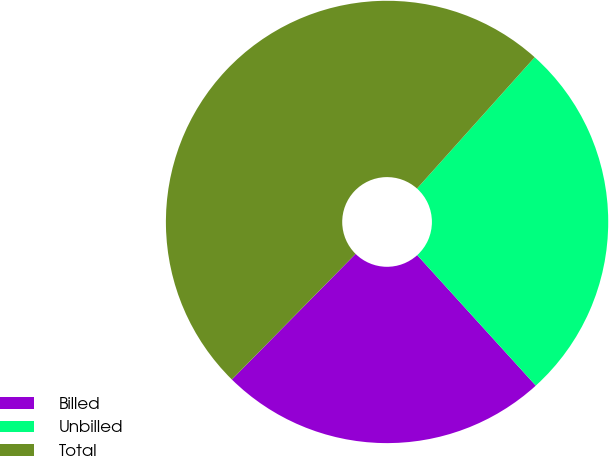Convert chart. <chart><loc_0><loc_0><loc_500><loc_500><pie_chart><fcel>Billed<fcel>Unbilled<fcel>Total<nl><fcel>24.12%<fcel>26.63%<fcel>49.25%<nl></chart> 